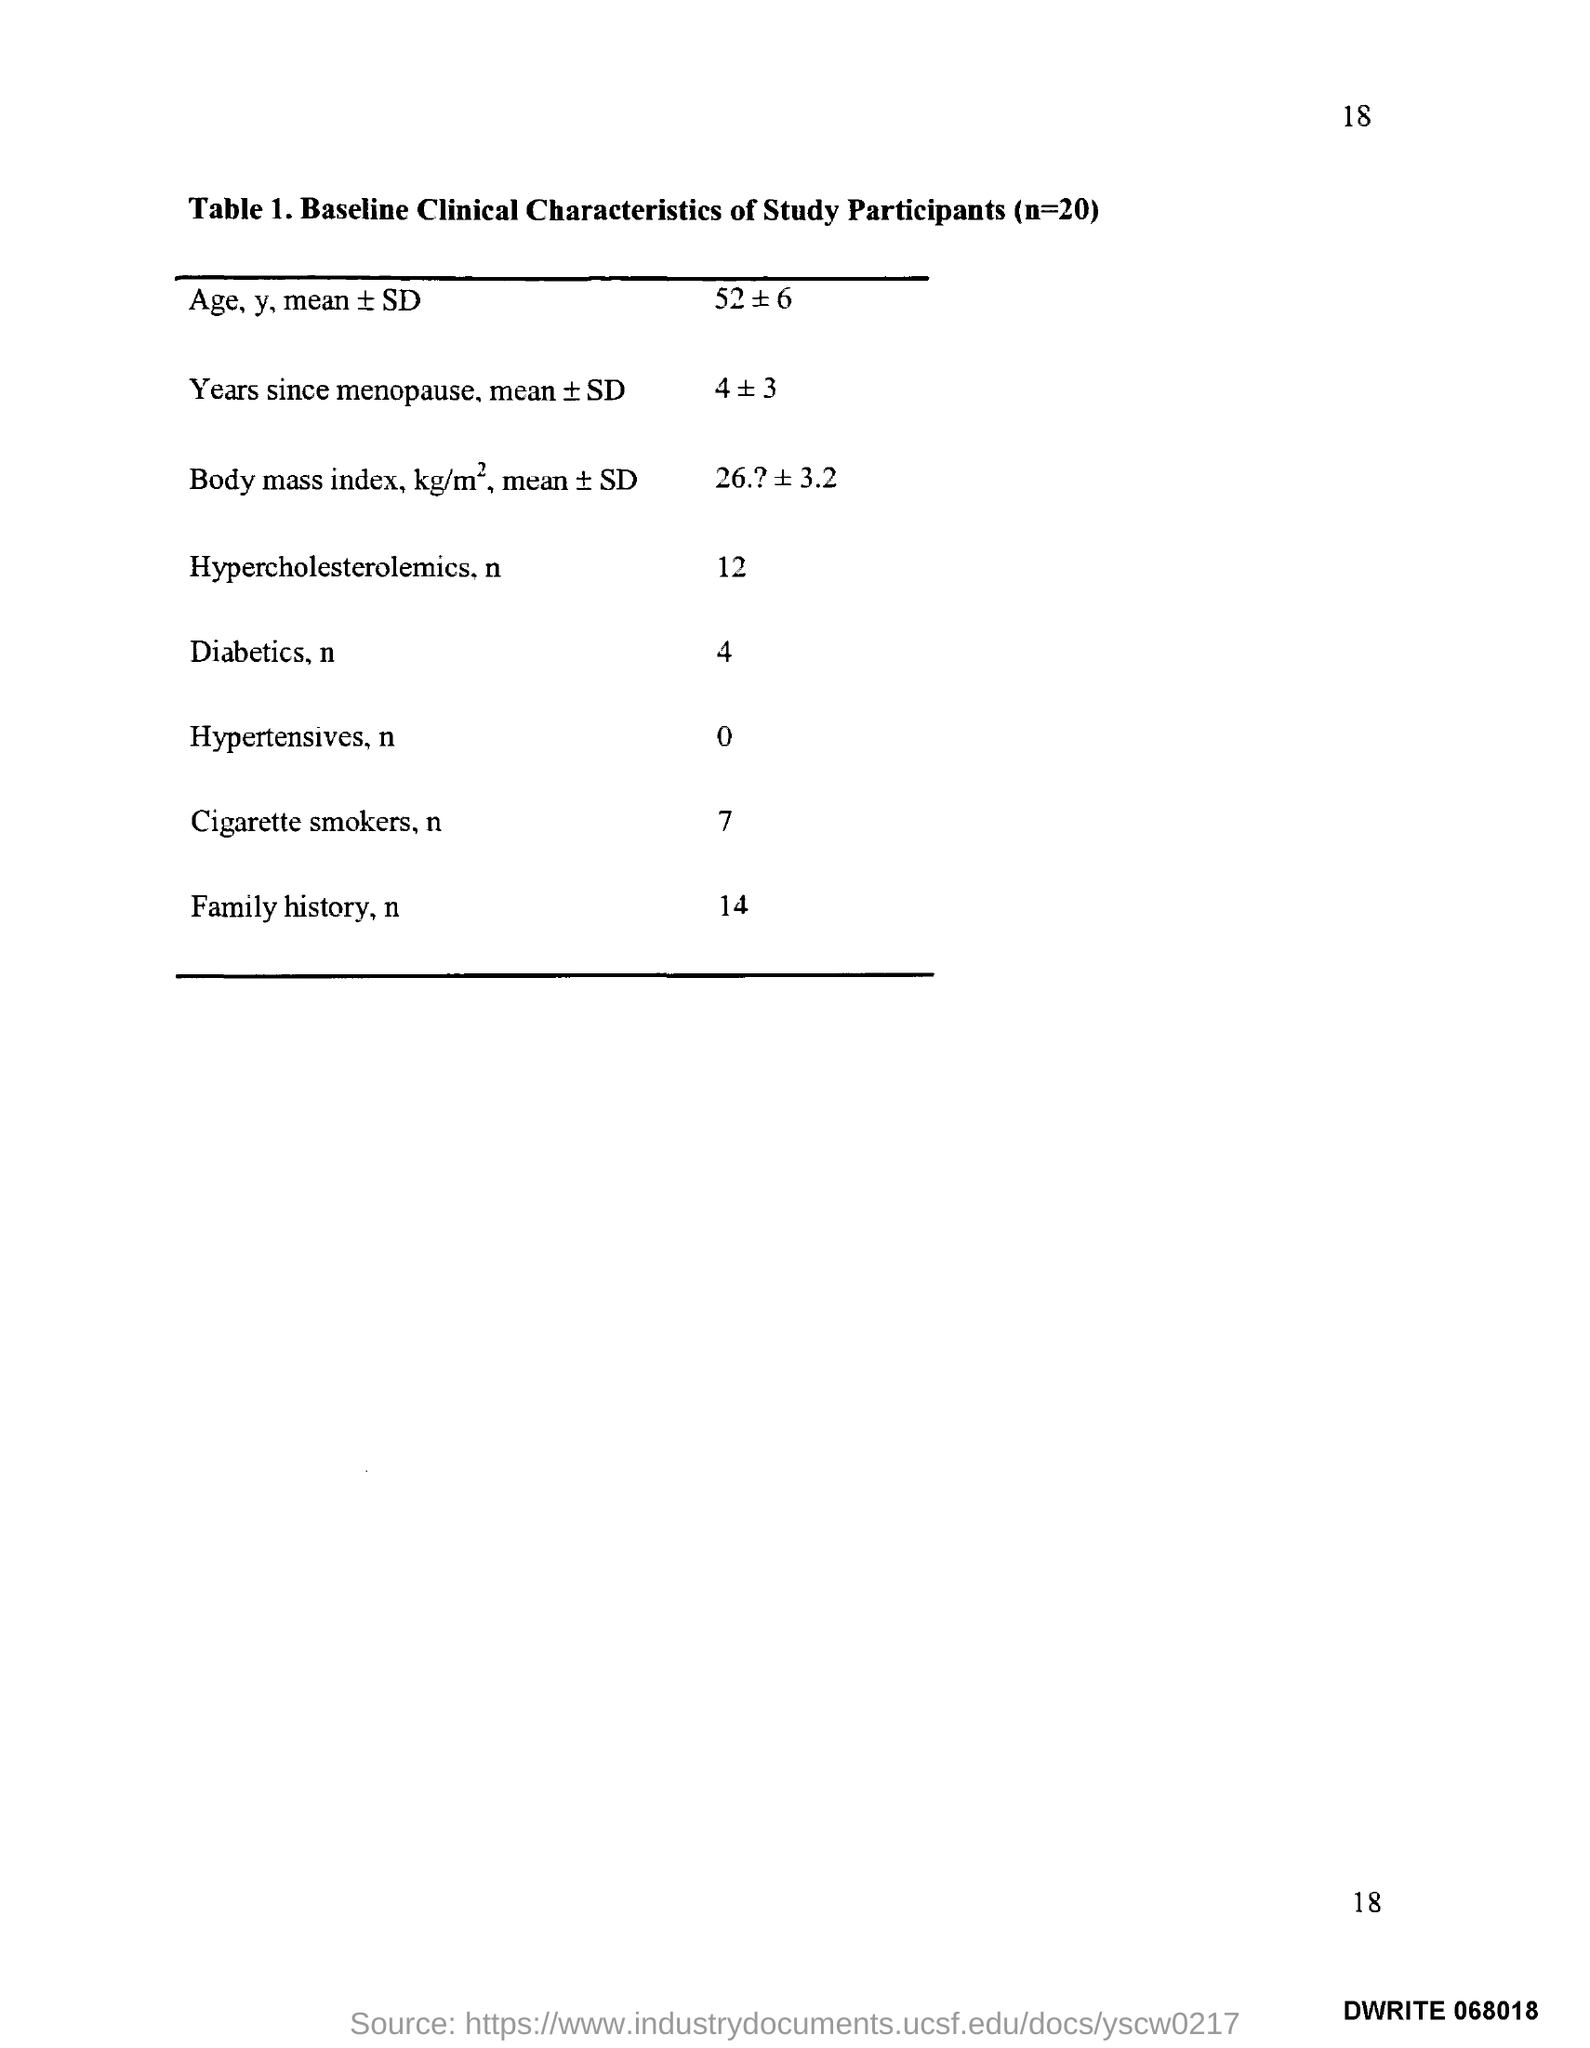Draw attention to some important aspects in this diagram. There are 7 million cigarette smokers in the world. The page number is 18," declares the speaker. 